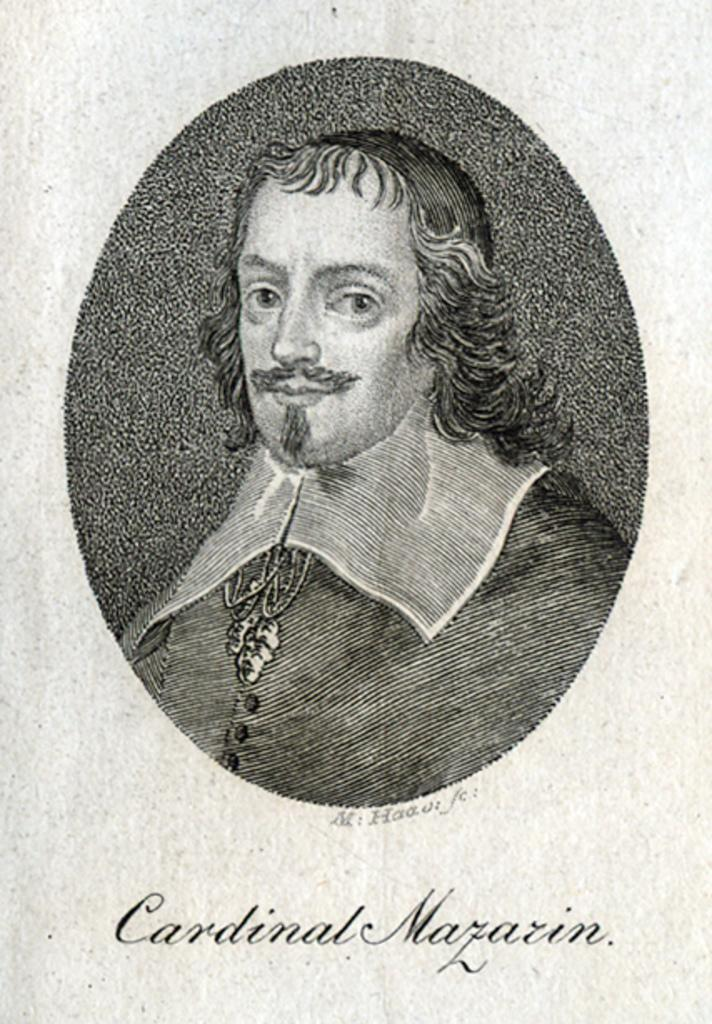What is the main subject of the image? There is a photo of a person in the image. What additional feature can be seen on the photo? There is text written on the photo. How many deer can be seen in the image? There are no deer present in the image; it features a photo of a person with text written on it. What is the price of the brain depicted in the image? There is no brain depicted in the image, and therefore no price can be determined. 